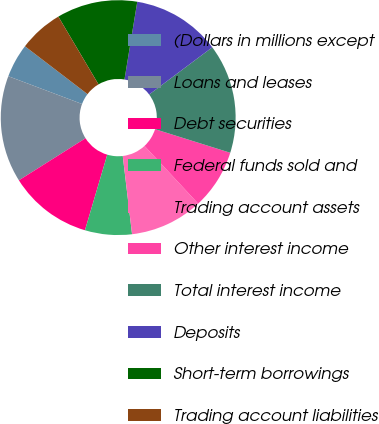Convert chart to OTSL. <chart><loc_0><loc_0><loc_500><loc_500><pie_chart><fcel>(Dollars in millions except<fcel>Loans and leases<fcel>Debt securities<fcel>Federal funds sold and<fcel>Trading account assets<fcel>Other interest income<fcel>Total interest income<fcel>Deposits<fcel>Short-term borrowings<fcel>Trading account liabilities<nl><fcel>4.66%<fcel>14.7%<fcel>11.47%<fcel>6.45%<fcel>10.04%<fcel>8.24%<fcel>15.05%<fcel>12.19%<fcel>11.11%<fcel>6.09%<nl></chart> 